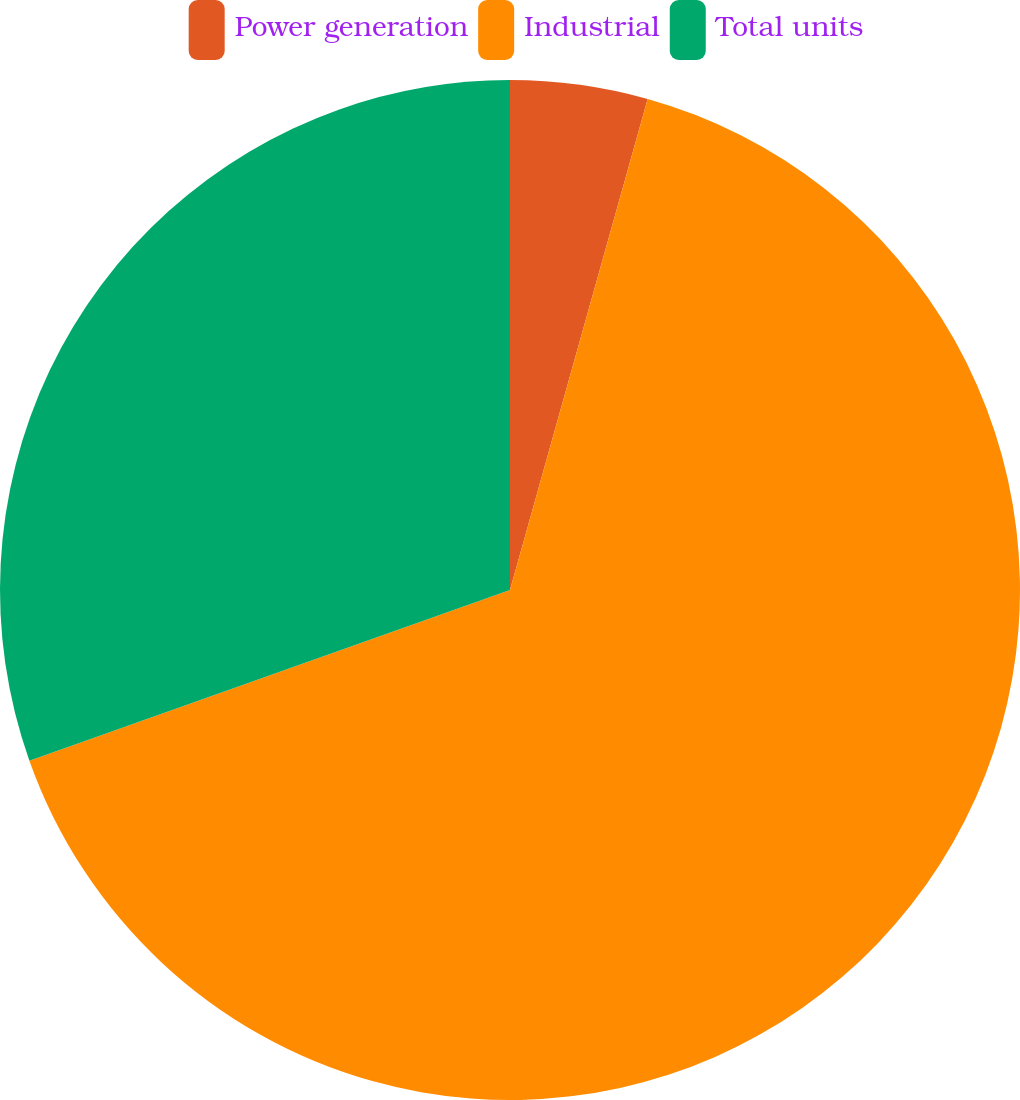Convert chart to OTSL. <chart><loc_0><loc_0><loc_500><loc_500><pie_chart><fcel>Power generation<fcel>Industrial<fcel>Total units<nl><fcel>4.35%<fcel>65.22%<fcel>30.43%<nl></chart> 